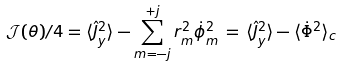Convert formula to latex. <formula><loc_0><loc_0><loc_500><loc_500>\mathcal { J } ( \theta ) / 4 = \langle \hat { J } _ { y } ^ { 2 } \rangle - \sum _ { m = - j } ^ { + j } r _ { m } ^ { 2 } \dot { \phi } _ { m } ^ { 2 } \, = \, \langle \hat { J } _ { y } ^ { 2 } \rangle - \langle \dot { \Phi } ^ { 2 } \rangle _ { c } \,</formula> 